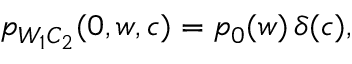Convert formula to latex. <formula><loc_0><loc_0><loc_500><loc_500>\begin{array} { r } { p _ { W _ { 1 } C _ { 2 } } ( 0 , w , c ) = p _ { 0 } ( w ) \, \delta ( c ) , } \end{array}</formula> 